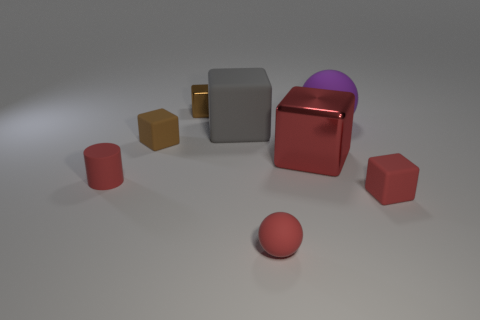The metal block that is the same color as the tiny cylinder is what size?
Give a very brief answer. Large. Do the matte cylinder and the tiny ball have the same color?
Provide a succinct answer. Yes. Are there any matte objects of the same color as the rubber cylinder?
Your response must be concise. Yes. The metallic thing that is the same size as the rubber cylinder is what color?
Ensure brevity in your answer.  Brown. What is the shape of the matte object that is the same color as the small metallic object?
Ensure brevity in your answer.  Cube. The purple thing that is the same size as the gray object is what shape?
Make the answer very short. Sphere. What shape is the red thing right of the red metallic thing?
Give a very brief answer. Cube. Is the number of tiny rubber cubes that are in front of the small brown rubber object the same as the number of small red blocks that are on the left side of the small red rubber block?
Ensure brevity in your answer.  No. How many things are either small cyan rubber blocks or shiny objects that are in front of the brown rubber thing?
Offer a very short reply. 1. The big object that is on the right side of the big gray cube and in front of the large purple object has what shape?
Your answer should be compact. Cube. 